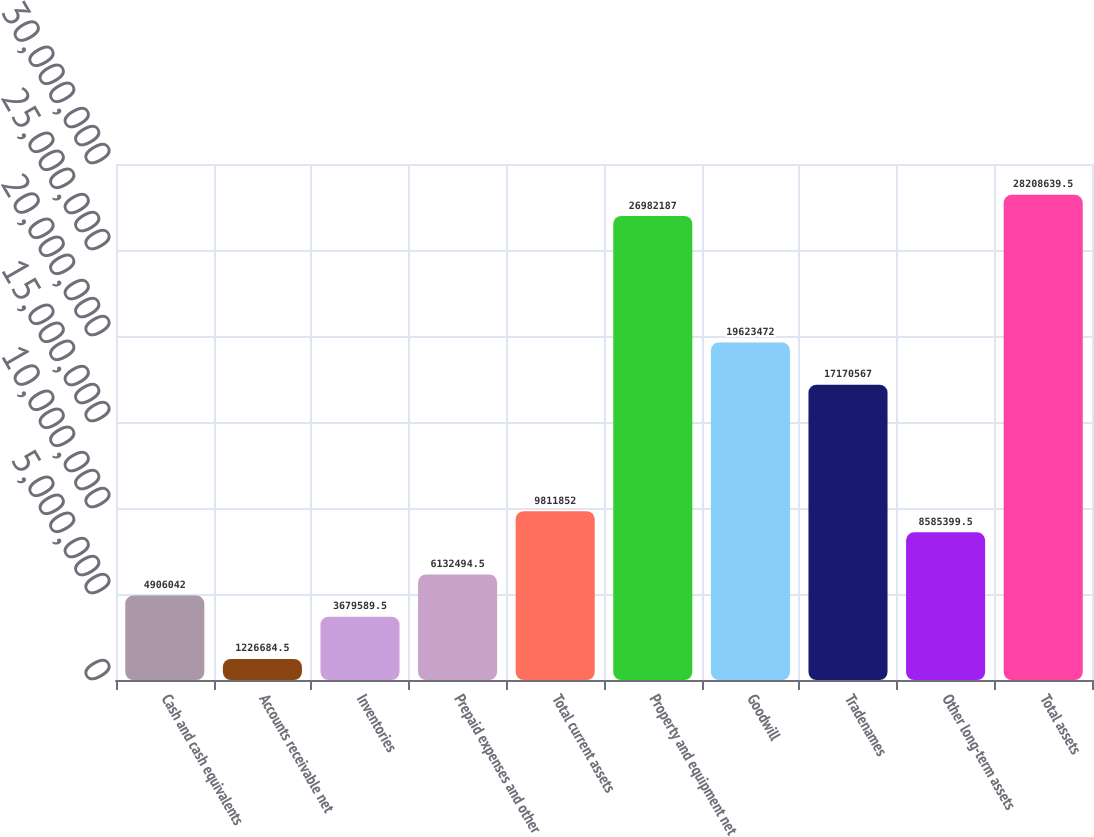Convert chart. <chart><loc_0><loc_0><loc_500><loc_500><bar_chart><fcel>Cash and cash equivalents<fcel>Accounts receivable net<fcel>Inventories<fcel>Prepaid expenses and other<fcel>Total current assets<fcel>Property and equipment net<fcel>Goodwill<fcel>Tradenames<fcel>Other long-term assets<fcel>Total assets<nl><fcel>4.90604e+06<fcel>1.22668e+06<fcel>3.67959e+06<fcel>6.13249e+06<fcel>9.81185e+06<fcel>2.69822e+07<fcel>1.96235e+07<fcel>1.71706e+07<fcel>8.5854e+06<fcel>2.82086e+07<nl></chart> 